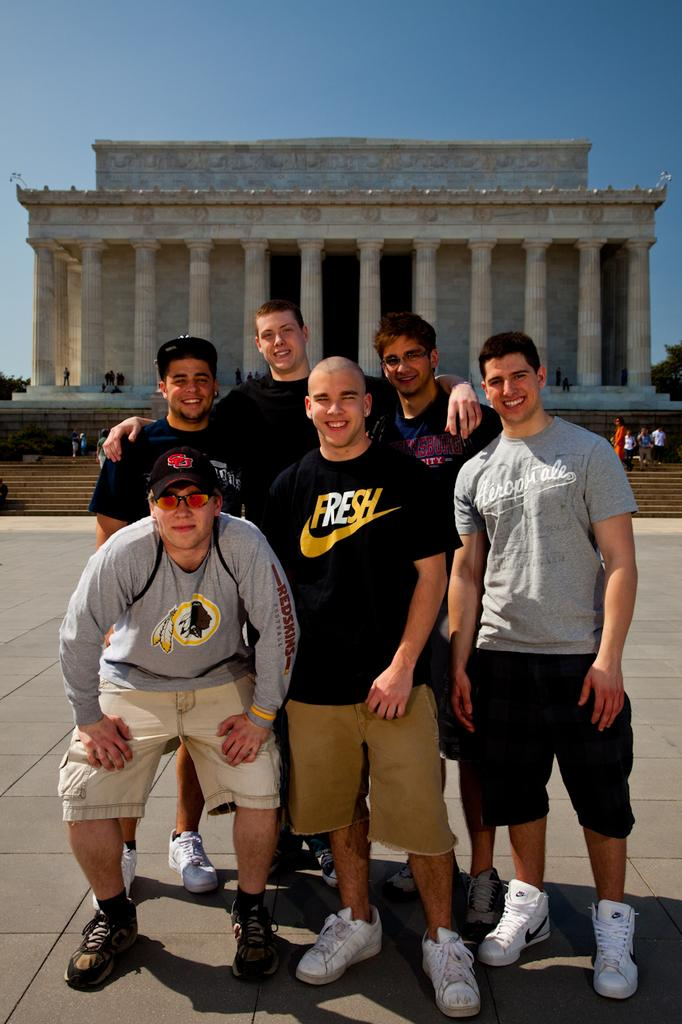<image>
Relay a brief, clear account of the picture shown. a man with a Nike shirt that says Fresh posing with friends 